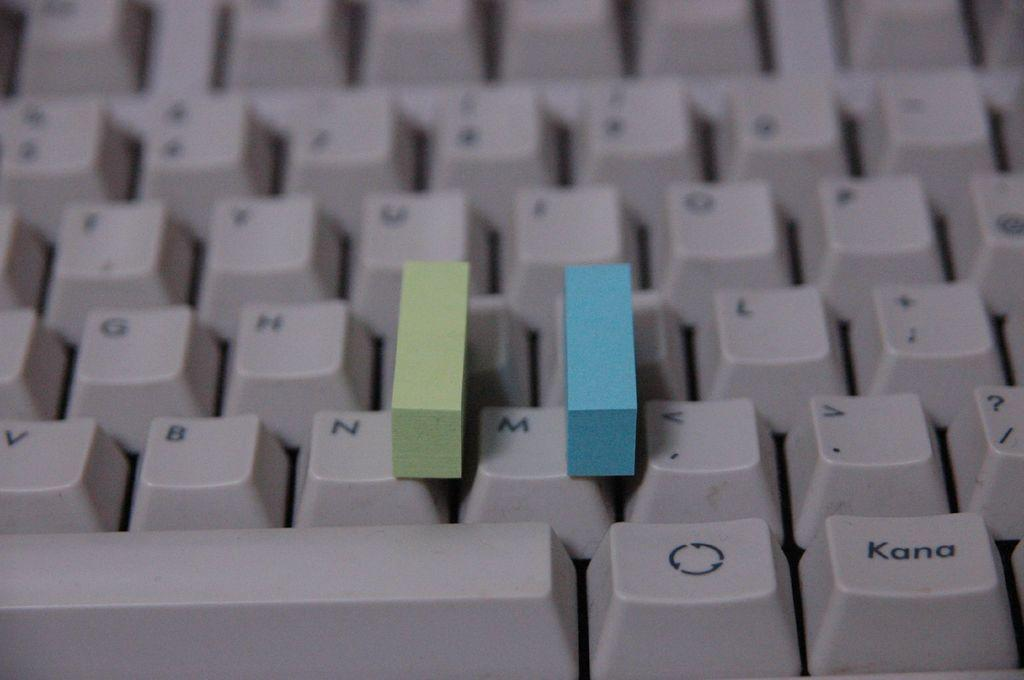Provide a one-sentence caption for the provided image. A keyboard with a green and blue block surrounding the letter M. 